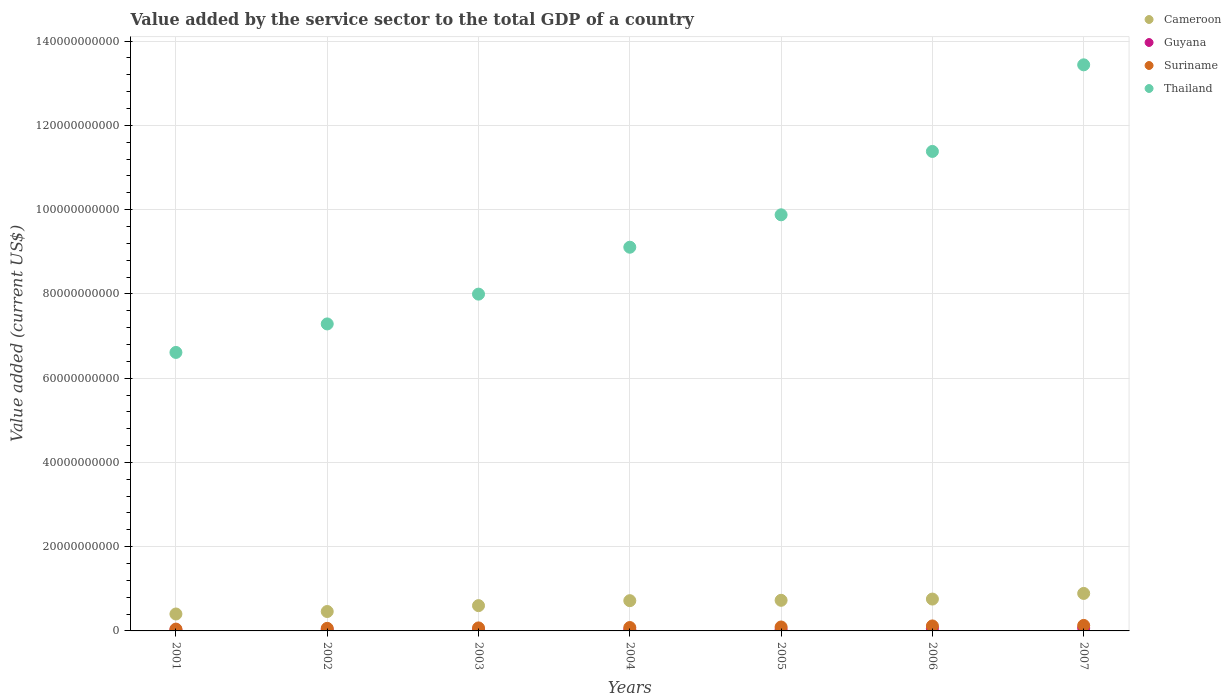Is the number of dotlines equal to the number of legend labels?
Your response must be concise. Yes. What is the value added by the service sector to the total GDP in Guyana in 2001?
Make the answer very short. 2.44e+08. Across all years, what is the maximum value added by the service sector to the total GDP in Thailand?
Ensure brevity in your answer.  1.34e+11. Across all years, what is the minimum value added by the service sector to the total GDP in Cameroon?
Your response must be concise. 4.02e+09. In which year was the value added by the service sector to the total GDP in Suriname maximum?
Make the answer very short. 2007. What is the total value added by the service sector to the total GDP in Cameroon in the graph?
Make the answer very short. 4.55e+1. What is the difference between the value added by the service sector to the total GDP in Thailand in 2005 and that in 2006?
Provide a succinct answer. -1.50e+1. What is the difference between the value added by the service sector to the total GDP in Thailand in 2006 and the value added by the service sector to the total GDP in Guyana in 2007?
Ensure brevity in your answer.  1.13e+11. What is the average value added by the service sector to the total GDP in Suriname per year?
Make the answer very short. 8.54e+08. In the year 2001, what is the difference between the value added by the service sector to the total GDP in Guyana and value added by the service sector to the total GDP in Suriname?
Offer a terse response. -1.87e+08. In how many years, is the value added by the service sector to the total GDP in Cameroon greater than 64000000000 US$?
Your response must be concise. 0. What is the ratio of the value added by the service sector to the total GDP in Cameroon in 2002 to that in 2005?
Your response must be concise. 0.63. Is the value added by the service sector to the total GDP in Guyana in 2001 less than that in 2007?
Your answer should be compact. Yes. What is the difference between the highest and the second highest value added by the service sector to the total GDP in Cameroon?
Ensure brevity in your answer.  1.34e+09. What is the difference between the highest and the lowest value added by the service sector to the total GDP in Suriname?
Ensure brevity in your answer.  8.72e+08. Is the value added by the service sector to the total GDP in Guyana strictly greater than the value added by the service sector to the total GDP in Cameroon over the years?
Your response must be concise. No. How many dotlines are there?
Give a very brief answer. 4. What is the difference between two consecutive major ticks on the Y-axis?
Your answer should be compact. 2.00e+1. Are the values on the major ticks of Y-axis written in scientific E-notation?
Your answer should be very brief. No. What is the title of the graph?
Your answer should be compact. Value added by the service sector to the total GDP of a country. Does "Sri Lanka" appear as one of the legend labels in the graph?
Offer a very short reply. No. What is the label or title of the X-axis?
Make the answer very short. Years. What is the label or title of the Y-axis?
Give a very brief answer. Value added (current US$). What is the Value added (current US$) of Cameroon in 2001?
Provide a succinct answer. 4.02e+09. What is the Value added (current US$) of Guyana in 2001?
Keep it short and to the point. 2.44e+08. What is the Value added (current US$) in Suriname in 2001?
Make the answer very short. 4.31e+08. What is the Value added (current US$) in Thailand in 2001?
Make the answer very short. 6.61e+1. What is the Value added (current US$) in Cameroon in 2002?
Offer a very short reply. 4.61e+09. What is the Value added (current US$) in Guyana in 2002?
Your response must be concise. 2.51e+08. What is the Value added (current US$) in Suriname in 2002?
Give a very brief answer. 6.11e+08. What is the Value added (current US$) in Thailand in 2002?
Provide a short and direct response. 7.29e+1. What is the Value added (current US$) in Cameroon in 2003?
Provide a short and direct response. 6.00e+09. What is the Value added (current US$) of Guyana in 2003?
Offer a very short reply. 2.63e+08. What is the Value added (current US$) in Suriname in 2003?
Offer a terse response. 7.13e+08. What is the Value added (current US$) in Thailand in 2003?
Provide a short and direct response. 7.99e+1. What is the Value added (current US$) in Cameroon in 2004?
Make the answer very short. 7.18e+09. What is the Value added (current US$) in Guyana in 2004?
Keep it short and to the point. 2.75e+08. What is the Value added (current US$) of Suriname in 2004?
Keep it short and to the point. 8.05e+08. What is the Value added (current US$) of Thailand in 2004?
Your answer should be compact. 9.11e+1. What is the Value added (current US$) of Cameroon in 2005?
Make the answer very short. 7.27e+09. What is the Value added (current US$) of Guyana in 2005?
Provide a short and direct response. 3.13e+08. What is the Value added (current US$) in Suriname in 2005?
Make the answer very short. 9.33e+08. What is the Value added (current US$) in Thailand in 2005?
Your response must be concise. 9.88e+1. What is the Value added (current US$) in Cameroon in 2006?
Give a very brief answer. 7.56e+09. What is the Value added (current US$) of Guyana in 2006?
Your answer should be compact. 6.05e+08. What is the Value added (current US$) of Suriname in 2006?
Provide a short and direct response. 1.18e+09. What is the Value added (current US$) of Thailand in 2006?
Provide a short and direct response. 1.14e+11. What is the Value added (current US$) in Cameroon in 2007?
Give a very brief answer. 8.90e+09. What is the Value added (current US$) of Guyana in 2007?
Offer a terse response. 6.90e+08. What is the Value added (current US$) of Suriname in 2007?
Give a very brief answer. 1.30e+09. What is the Value added (current US$) of Thailand in 2007?
Provide a short and direct response. 1.34e+11. Across all years, what is the maximum Value added (current US$) in Cameroon?
Make the answer very short. 8.90e+09. Across all years, what is the maximum Value added (current US$) in Guyana?
Offer a very short reply. 6.90e+08. Across all years, what is the maximum Value added (current US$) in Suriname?
Ensure brevity in your answer.  1.30e+09. Across all years, what is the maximum Value added (current US$) of Thailand?
Make the answer very short. 1.34e+11. Across all years, what is the minimum Value added (current US$) in Cameroon?
Offer a terse response. 4.02e+09. Across all years, what is the minimum Value added (current US$) in Guyana?
Provide a succinct answer. 2.44e+08. Across all years, what is the minimum Value added (current US$) of Suriname?
Make the answer very short. 4.31e+08. Across all years, what is the minimum Value added (current US$) in Thailand?
Make the answer very short. 6.61e+1. What is the total Value added (current US$) of Cameroon in the graph?
Your answer should be compact. 4.55e+1. What is the total Value added (current US$) of Guyana in the graph?
Give a very brief answer. 2.64e+09. What is the total Value added (current US$) of Suriname in the graph?
Make the answer very short. 5.98e+09. What is the total Value added (current US$) of Thailand in the graph?
Offer a terse response. 6.57e+11. What is the difference between the Value added (current US$) in Cameroon in 2001 and that in 2002?
Keep it short and to the point. -5.90e+08. What is the difference between the Value added (current US$) in Guyana in 2001 and that in 2002?
Offer a terse response. -6.45e+06. What is the difference between the Value added (current US$) in Suriname in 2001 and that in 2002?
Provide a short and direct response. -1.80e+08. What is the difference between the Value added (current US$) of Thailand in 2001 and that in 2002?
Your answer should be compact. -6.77e+09. What is the difference between the Value added (current US$) in Cameroon in 2001 and that in 2003?
Keep it short and to the point. -1.98e+09. What is the difference between the Value added (current US$) of Guyana in 2001 and that in 2003?
Keep it short and to the point. -1.88e+07. What is the difference between the Value added (current US$) in Suriname in 2001 and that in 2003?
Give a very brief answer. -2.82e+08. What is the difference between the Value added (current US$) of Thailand in 2001 and that in 2003?
Make the answer very short. -1.38e+1. What is the difference between the Value added (current US$) in Cameroon in 2001 and that in 2004?
Offer a very short reply. -3.16e+09. What is the difference between the Value added (current US$) in Guyana in 2001 and that in 2004?
Make the answer very short. -3.04e+07. What is the difference between the Value added (current US$) in Suriname in 2001 and that in 2004?
Ensure brevity in your answer.  -3.74e+08. What is the difference between the Value added (current US$) of Thailand in 2001 and that in 2004?
Your answer should be compact. -2.50e+1. What is the difference between the Value added (current US$) in Cameroon in 2001 and that in 2005?
Give a very brief answer. -3.25e+09. What is the difference between the Value added (current US$) of Guyana in 2001 and that in 2005?
Make the answer very short. -6.85e+07. What is the difference between the Value added (current US$) in Suriname in 2001 and that in 2005?
Your answer should be very brief. -5.02e+08. What is the difference between the Value added (current US$) in Thailand in 2001 and that in 2005?
Offer a terse response. -3.27e+1. What is the difference between the Value added (current US$) of Cameroon in 2001 and that in 2006?
Ensure brevity in your answer.  -3.54e+09. What is the difference between the Value added (current US$) of Guyana in 2001 and that in 2006?
Offer a very short reply. -3.61e+08. What is the difference between the Value added (current US$) of Suriname in 2001 and that in 2006?
Ensure brevity in your answer.  -7.52e+08. What is the difference between the Value added (current US$) of Thailand in 2001 and that in 2006?
Provide a short and direct response. -4.77e+1. What is the difference between the Value added (current US$) in Cameroon in 2001 and that in 2007?
Ensure brevity in your answer.  -4.88e+09. What is the difference between the Value added (current US$) of Guyana in 2001 and that in 2007?
Keep it short and to the point. -4.45e+08. What is the difference between the Value added (current US$) of Suriname in 2001 and that in 2007?
Your response must be concise. -8.72e+08. What is the difference between the Value added (current US$) in Thailand in 2001 and that in 2007?
Your answer should be compact. -6.83e+1. What is the difference between the Value added (current US$) in Cameroon in 2002 and that in 2003?
Provide a short and direct response. -1.39e+09. What is the difference between the Value added (current US$) in Guyana in 2002 and that in 2003?
Give a very brief answer. -1.23e+07. What is the difference between the Value added (current US$) in Suriname in 2002 and that in 2003?
Give a very brief answer. -1.02e+08. What is the difference between the Value added (current US$) in Thailand in 2002 and that in 2003?
Your answer should be compact. -7.07e+09. What is the difference between the Value added (current US$) in Cameroon in 2002 and that in 2004?
Provide a succinct answer. -2.57e+09. What is the difference between the Value added (current US$) of Guyana in 2002 and that in 2004?
Make the answer very short. -2.39e+07. What is the difference between the Value added (current US$) in Suriname in 2002 and that in 2004?
Make the answer very short. -1.94e+08. What is the difference between the Value added (current US$) in Thailand in 2002 and that in 2004?
Keep it short and to the point. -1.82e+1. What is the difference between the Value added (current US$) of Cameroon in 2002 and that in 2005?
Provide a succinct answer. -2.66e+09. What is the difference between the Value added (current US$) in Guyana in 2002 and that in 2005?
Your response must be concise. -6.21e+07. What is the difference between the Value added (current US$) in Suriname in 2002 and that in 2005?
Offer a terse response. -3.22e+08. What is the difference between the Value added (current US$) in Thailand in 2002 and that in 2005?
Make the answer very short. -2.59e+1. What is the difference between the Value added (current US$) of Cameroon in 2002 and that in 2006?
Make the answer very short. -2.95e+09. What is the difference between the Value added (current US$) of Guyana in 2002 and that in 2006?
Provide a succinct answer. -3.55e+08. What is the difference between the Value added (current US$) in Suriname in 2002 and that in 2006?
Keep it short and to the point. -5.72e+08. What is the difference between the Value added (current US$) in Thailand in 2002 and that in 2006?
Your answer should be compact. -4.09e+1. What is the difference between the Value added (current US$) in Cameroon in 2002 and that in 2007?
Make the answer very short. -4.29e+09. What is the difference between the Value added (current US$) in Guyana in 2002 and that in 2007?
Ensure brevity in your answer.  -4.39e+08. What is the difference between the Value added (current US$) in Suriname in 2002 and that in 2007?
Your answer should be very brief. -6.92e+08. What is the difference between the Value added (current US$) of Thailand in 2002 and that in 2007?
Your answer should be very brief. -6.15e+1. What is the difference between the Value added (current US$) of Cameroon in 2003 and that in 2004?
Ensure brevity in your answer.  -1.18e+09. What is the difference between the Value added (current US$) in Guyana in 2003 and that in 2004?
Your answer should be compact. -1.16e+07. What is the difference between the Value added (current US$) in Suriname in 2003 and that in 2004?
Offer a very short reply. -9.21e+07. What is the difference between the Value added (current US$) in Thailand in 2003 and that in 2004?
Provide a succinct answer. -1.11e+1. What is the difference between the Value added (current US$) in Cameroon in 2003 and that in 2005?
Your response must be concise. -1.27e+09. What is the difference between the Value added (current US$) in Guyana in 2003 and that in 2005?
Ensure brevity in your answer.  -4.98e+07. What is the difference between the Value added (current US$) of Suriname in 2003 and that in 2005?
Make the answer very short. -2.20e+08. What is the difference between the Value added (current US$) in Thailand in 2003 and that in 2005?
Give a very brief answer. -1.88e+1. What is the difference between the Value added (current US$) in Cameroon in 2003 and that in 2006?
Provide a succinct answer. -1.56e+09. What is the difference between the Value added (current US$) in Guyana in 2003 and that in 2006?
Make the answer very short. -3.42e+08. What is the difference between the Value added (current US$) in Suriname in 2003 and that in 2006?
Your response must be concise. -4.70e+08. What is the difference between the Value added (current US$) in Thailand in 2003 and that in 2006?
Make the answer very short. -3.39e+1. What is the difference between the Value added (current US$) of Cameroon in 2003 and that in 2007?
Offer a terse response. -2.90e+09. What is the difference between the Value added (current US$) in Guyana in 2003 and that in 2007?
Your answer should be compact. -4.27e+08. What is the difference between the Value added (current US$) in Suriname in 2003 and that in 2007?
Keep it short and to the point. -5.90e+08. What is the difference between the Value added (current US$) of Thailand in 2003 and that in 2007?
Ensure brevity in your answer.  -5.44e+1. What is the difference between the Value added (current US$) of Cameroon in 2004 and that in 2005?
Offer a terse response. -8.73e+07. What is the difference between the Value added (current US$) in Guyana in 2004 and that in 2005?
Your answer should be compact. -3.82e+07. What is the difference between the Value added (current US$) in Suriname in 2004 and that in 2005?
Give a very brief answer. -1.28e+08. What is the difference between the Value added (current US$) in Thailand in 2004 and that in 2005?
Ensure brevity in your answer.  -7.70e+09. What is the difference between the Value added (current US$) of Cameroon in 2004 and that in 2006?
Ensure brevity in your answer.  -3.81e+08. What is the difference between the Value added (current US$) of Guyana in 2004 and that in 2006?
Your answer should be compact. -3.31e+08. What is the difference between the Value added (current US$) of Suriname in 2004 and that in 2006?
Give a very brief answer. -3.78e+08. What is the difference between the Value added (current US$) of Thailand in 2004 and that in 2006?
Ensure brevity in your answer.  -2.27e+1. What is the difference between the Value added (current US$) of Cameroon in 2004 and that in 2007?
Provide a succinct answer. -1.72e+09. What is the difference between the Value added (current US$) of Guyana in 2004 and that in 2007?
Give a very brief answer. -4.15e+08. What is the difference between the Value added (current US$) of Suriname in 2004 and that in 2007?
Offer a terse response. -4.98e+08. What is the difference between the Value added (current US$) of Thailand in 2004 and that in 2007?
Provide a succinct answer. -4.33e+1. What is the difference between the Value added (current US$) in Cameroon in 2005 and that in 2006?
Make the answer very short. -2.94e+08. What is the difference between the Value added (current US$) in Guyana in 2005 and that in 2006?
Offer a terse response. -2.92e+08. What is the difference between the Value added (current US$) in Suriname in 2005 and that in 2006?
Offer a terse response. -2.50e+08. What is the difference between the Value added (current US$) of Thailand in 2005 and that in 2006?
Your response must be concise. -1.50e+1. What is the difference between the Value added (current US$) in Cameroon in 2005 and that in 2007?
Your answer should be very brief. -1.63e+09. What is the difference between the Value added (current US$) of Guyana in 2005 and that in 2007?
Your answer should be compact. -3.77e+08. What is the difference between the Value added (current US$) of Suriname in 2005 and that in 2007?
Offer a very short reply. -3.70e+08. What is the difference between the Value added (current US$) of Thailand in 2005 and that in 2007?
Ensure brevity in your answer.  -3.56e+1. What is the difference between the Value added (current US$) of Cameroon in 2006 and that in 2007?
Offer a terse response. -1.34e+09. What is the difference between the Value added (current US$) of Guyana in 2006 and that in 2007?
Give a very brief answer. -8.43e+07. What is the difference between the Value added (current US$) in Suriname in 2006 and that in 2007?
Your answer should be compact. -1.20e+08. What is the difference between the Value added (current US$) of Thailand in 2006 and that in 2007?
Make the answer very short. -2.06e+1. What is the difference between the Value added (current US$) of Cameroon in 2001 and the Value added (current US$) of Guyana in 2002?
Offer a terse response. 3.77e+09. What is the difference between the Value added (current US$) in Cameroon in 2001 and the Value added (current US$) in Suriname in 2002?
Ensure brevity in your answer.  3.41e+09. What is the difference between the Value added (current US$) in Cameroon in 2001 and the Value added (current US$) in Thailand in 2002?
Your answer should be compact. -6.89e+1. What is the difference between the Value added (current US$) of Guyana in 2001 and the Value added (current US$) of Suriname in 2002?
Provide a succinct answer. -3.67e+08. What is the difference between the Value added (current US$) of Guyana in 2001 and the Value added (current US$) of Thailand in 2002?
Your response must be concise. -7.26e+1. What is the difference between the Value added (current US$) of Suriname in 2001 and the Value added (current US$) of Thailand in 2002?
Keep it short and to the point. -7.24e+1. What is the difference between the Value added (current US$) in Cameroon in 2001 and the Value added (current US$) in Guyana in 2003?
Your response must be concise. 3.75e+09. What is the difference between the Value added (current US$) of Cameroon in 2001 and the Value added (current US$) of Suriname in 2003?
Your response must be concise. 3.30e+09. What is the difference between the Value added (current US$) of Cameroon in 2001 and the Value added (current US$) of Thailand in 2003?
Your response must be concise. -7.59e+1. What is the difference between the Value added (current US$) in Guyana in 2001 and the Value added (current US$) in Suriname in 2003?
Keep it short and to the point. -4.69e+08. What is the difference between the Value added (current US$) of Guyana in 2001 and the Value added (current US$) of Thailand in 2003?
Make the answer very short. -7.97e+1. What is the difference between the Value added (current US$) in Suriname in 2001 and the Value added (current US$) in Thailand in 2003?
Ensure brevity in your answer.  -7.95e+1. What is the difference between the Value added (current US$) of Cameroon in 2001 and the Value added (current US$) of Guyana in 2004?
Give a very brief answer. 3.74e+09. What is the difference between the Value added (current US$) of Cameroon in 2001 and the Value added (current US$) of Suriname in 2004?
Make the answer very short. 3.21e+09. What is the difference between the Value added (current US$) in Cameroon in 2001 and the Value added (current US$) in Thailand in 2004?
Your response must be concise. -8.71e+1. What is the difference between the Value added (current US$) in Guyana in 2001 and the Value added (current US$) in Suriname in 2004?
Give a very brief answer. -5.61e+08. What is the difference between the Value added (current US$) of Guyana in 2001 and the Value added (current US$) of Thailand in 2004?
Keep it short and to the point. -9.08e+1. What is the difference between the Value added (current US$) in Suriname in 2001 and the Value added (current US$) in Thailand in 2004?
Give a very brief answer. -9.06e+1. What is the difference between the Value added (current US$) in Cameroon in 2001 and the Value added (current US$) in Guyana in 2005?
Provide a succinct answer. 3.70e+09. What is the difference between the Value added (current US$) of Cameroon in 2001 and the Value added (current US$) of Suriname in 2005?
Keep it short and to the point. 3.08e+09. What is the difference between the Value added (current US$) in Cameroon in 2001 and the Value added (current US$) in Thailand in 2005?
Make the answer very short. -9.48e+1. What is the difference between the Value added (current US$) in Guyana in 2001 and the Value added (current US$) in Suriname in 2005?
Make the answer very short. -6.88e+08. What is the difference between the Value added (current US$) of Guyana in 2001 and the Value added (current US$) of Thailand in 2005?
Keep it short and to the point. -9.85e+1. What is the difference between the Value added (current US$) of Suriname in 2001 and the Value added (current US$) of Thailand in 2005?
Your response must be concise. -9.83e+1. What is the difference between the Value added (current US$) in Cameroon in 2001 and the Value added (current US$) in Guyana in 2006?
Offer a very short reply. 3.41e+09. What is the difference between the Value added (current US$) of Cameroon in 2001 and the Value added (current US$) of Suriname in 2006?
Keep it short and to the point. 2.83e+09. What is the difference between the Value added (current US$) of Cameroon in 2001 and the Value added (current US$) of Thailand in 2006?
Your answer should be very brief. -1.10e+11. What is the difference between the Value added (current US$) of Guyana in 2001 and the Value added (current US$) of Suriname in 2006?
Provide a succinct answer. -9.39e+08. What is the difference between the Value added (current US$) in Guyana in 2001 and the Value added (current US$) in Thailand in 2006?
Keep it short and to the point. -1.14e+11. What is the difference between the Value added (current US$) of Suriname in 2001 and the Value added (current US$) of Thailand in 2006?
Provide a succinct answer. -1.13e+11. What is the difference between the Value added (current US$) in Cameroon in 2001 and the Value added (current US$) in Guyana in 2007?
Your answer should be very brief. 3.33e+09. What is the difference between the Value added (current US$) of Cameroon in 2001 and the Value added (current US$) of Suriname in 2007?
Provide a short and direct response. 2.71e+09. What is the difference between the Value added (current US$) of Cameroon in 2001 and the Value added (current US$) of Thailand in 2007?
Provide a short and direct response. -1.30e+11. What is the difference between the Value added (current US$) in Guyana in 2001 and the Value added (current US$) in Suriname in 2007?
Provide a succinct answer. -1.06e+09. What is the difference between the Value added (current US$) in Guyana in 2001 and the Value added (current US$) in Thailand in 2007?
Give a very brief answer. -1.34e+11. What is the difference between the Value added (current US$) of Suriname in 2001 and the Value added (current US$) of Thailand in 2007?
Your response must be concise. -1.34e+11. What is the difference between the Value added (current US$) in Cameroon in 2002 and the Value added (current US$) in Guyana in 2003?
Provide a short and direct response. 4.34e+09. What is the difference between the Value added (current US$) of Cameroon in 2002 and the Value added (current US$) of Suriname in 2003?
Provide a short and direct response. 3.89e+09. What is the difference between the Value added (current US$) of Cameroon in 2002 and the Value added (current US$) of Thailand in 2003?
Your response must be concise. -7.53e+1. What is the difference between the Value added (current US$) of Guyana in 2002 and the Value added (current US$) of Suriname in 2003?
Offer a terse response. -4.62e+08. What is the difference between the Value added (current US$) of Guyana in 2002 and the Value added (current US$) of Thailand in 2003?
Your answer should be very brief. -7.97e+1. What is the difference between the Value added (current US$) of Suriname in 2002 and the Value added (current US$) of Thailand in 2003?
Offer a terse response. -7.93e+1. What is the difference between the Value added (current US$) of Cameroon in 2002 and the Value added (current US$) of Guyana in 2004?
Your response must be concise. 4.33e+09. What is the difference between the Value added (current US$) of Cameroon in 2002 and the Value added (current US$) of Suriname in 2004?
Give a very brief answer. 3.80e+09. What is the difference between the Value added (current US$) of Cameroon in 2002 and the Value added (current US$) of Thailand in 2004?
Your answer should be very brief. -8.65e+1. What is the difference between the Value added (current US$) in Guyana in 2002 and the Value added (current US$) in Suriname in 2004?
Your response must be concise. -5.54e+08. What is the difference between the Value added (current US$) of Guyana in 2002 and the Value added (current US$) of Thailand in 2004?
Your answer should be very brief. -9.08e+1. What is the difference between the Value added (current US$) in Suriname in 2002 and the Value added (current US$) in Thailand in 2004?
Offer a terse response. -9.05e+1. What is the difference between the Value added (current US$) of Cameroon in 2002 and the Value added (current US$) of Guyana in 2005?
Your answer should be very brief. 4.29e+09. What is the difference between the Value added (current US$) of Cameroon in 2002 and the Value added (current US$) of Suriname in 2005?
Your answer should be very brief. 3.68e+09. What is the difference between the Value added (current US$) of Cameroon in 2002 and the Value added (current US$) of Thailand in 2005?
Ensure brevity in your answer.  -9.42e+1. What is the difference between the Value added (current US$) in Guyana in 2002 and the Value added (current US$) in Suriname in 2005?
Ensure brevity in your answer.  -6.82e+08. What is the difference between the Value added (current US$) in Guyana in 2002 and the Value added (current US$) in Thailand in 2005?
Your answer should be compact. -9.85e+1. What is the difference between the Value added (current US$) of Suriname in 2002 and the Value added (current US$) of Thailand in 2005?
Keep it short and to the point. -9.82e+1. What is the difference between the Value added (current US$) of Cameroon in 2002 and the Value added (current US$) of Guyana in 2006?
Offer a very short reply. 4.00e+09. What is the difference between the Value added (current US$) of Cameroon in 2002 and the Value added (current US$) of Suriname in 2006?
Make the answer very short. 3.42e+09. What is the difference between the Value added (current US$) in Cameroon in 2002 and the Value added (current US$) in Thailand in 2006?
Provide a succinct answer. -1.09e+11. What is the difference between the Value added (current US$) of Guyana in 2002 and the Value added (current US$) of Suriname in 2006?
Provide a succinct answer. -9.32e+08. What is the difference between the Value added (current US$) of Guyana in 2002 and the Value added (current US$) of Thailand in 2006?
Make the answer very short. -1.14e+11. What is the difference between the Value added (current US$) in Suriname in 2002 and the Value added (current US$) in Thailand in 2006?
Provide a short and direct response. -1.13e+11. What is the difference between the Value added (current US$) in Cameroon in 2002 and the Value added (current US$) in Guyana in 2007?
Give a very brief answer. 3.92e+09. What is the difference between the Value added (current US$) of Cameroon in 2002 and the Value added (current US$) of Suriname in 2007?
Provide a short and direct response. 3.30e+09. What is the difference between the Value added (current US$) of Cameroon in 2002 and the Value added (current US$) of Thailand in 2007?
Ensure brevity in your answer.  -1.30e+11. What is the difference between the Value added (current US$) in Guyana in 2002 and the Value added (current US$) in Suriname in 2007?
Provide a short and direct response. -1.05e+09. What is the difference between the Value added (current US$) in Guyana in 2002 and the Value added (current US$) in Thailand in 2007?
Give a very brief answer. -1.34e+11. What is the difference between the Value added (current US$) of Suriname in 2002 and the Value added (current US$) of Thailand in 2007?
Your response must be concise. -1.34e+11. What is the difference between the Value added (current US$) in Cameroon in 2003 and the Value added (current US$) in Guyana in 2004?
Your response must be concise. 5.73e+09. What is the difference between the Value added (current US$) of Cameroon in 2003 and the Value added (current US$) of Suriname in 2004?
Your response must be concise. 5.20e+09. What is the difference between the Value added (current US$) of Cameroon in 2003 and the Value added (current US$) of Thailand in 2004?
Provide a succinct answer. -8.51e+1. What is the difference between the Value added (current US$) in Guyana in 2003 and the Value added (current US$) in Suriname in 2004?
Provide a succinct answer. -5.42e+08. What is the difference between the Value added (current US$) of Guyana in 2003 and the Value added (current US$) of Thailand in 2004?
Offer a very short reply. -9.08e+1. What is the difference between the Value added (current US$) in Suriname in 2003 and the Value added (current US$) in Thailand in 2004?
Offer a terse response. -9.04e+1. What is the difference between the Value added (current US$) of Cameroon in 2003 and the Value added (current US$) of Guyana in 2005?
Your answer should be compact. 5.69e+09. What is the difference between the Value added (current US$) in Cameroon in 2003 and the Value added (current US$) in Suriname in 2005?
Offer a terse response. 5.07e+09. What is the difference between the Value added (current US$) of Cameroon in 2003 and the Value added (current US$) of Thailand in 2005?
Offer a very short reply. -9.28e+1. What is the difference between the Value added (current US$) in Guyana in 2003 and the Value added (current US$) in Suriname in 2005?
Your answer should be very brief. -6.70e+08. What is the difference between the Value added (current US$) in Guyana in 2003 and the Value added (current US$) in Thailand in 2005?
Offer a very short reply. -9.85e+1. What is the difference between the Value added (current US$) in Suriname in 2003 and the Value added (current US$) in Thailand in 2005?
Give a very brief answer. -9.81e+1. What is the difference between the Value added (current US$) of Cameroon in 2003 and the Value added (current US$) of Guyana in 2006?
Give a very brief answer. 5.40e+09. What is the difference between the Value added (current US$) of Cameroon in 2003 and the Value added (current US$) of Suriname in 2006?
Give a very brief answer. 4.82e+09. What is the difference between the Value added (current US$) of Cameroon in 2003 and the Value added (current US$) of Thailand in 2006?
Make the answer very short. -1.08e+11. What is the difference between the Value added (current US$) in Guyana in 2003 and the Value added (current US$) in Suriname in 2006?
Provide a succinct answer. -9.20e+08. What is the difference between the Value added (current US$) of Guyana in 2003 and the Value added (current US$) of Thailand in 2006?
Your response must be concise. -1.14e+11. What is the difference between the Value added (current US$) of Suriname in 2003 and the Value added (current US$) of Thailand in 2006?
Keep it short and to the point. -1.13e+11. What is the difference between the Value added (current US$) of Cameroon in 2003 and the Value added (current US$) of Guyana in 2007?
Provide a short and direct response. 5.31e+09. What is the difference between the Value added (current US$) in Cameroon in 2003 and the Value added (current US$) in Suriname in 2007?
Provide a succinct answer. 4.70e+09. What is the difference between the Value added (current US$) in Cameroon in 2003 and the Value added (current US$) in Thailand in 2007?
Offer a terse response. -1.28e+11. What is the difference between the Value added (current US$) of Guyana in 2003 and the Value added (current US$) of Suriname in 2007?
Your answer should be compact. -1.04e+09. What is the difference between the Value added (current US$) in Guyana in 2003 and the Value added (current US$) in Thailand in 2007?
Make the answer very short. -1.34e+11. What is the difference between the Value added (current US$) in Suriname in 2003 and the Value added (current US$) in Thailand in 2007?
Offer a terse response. -1.34e+11. What is the difference between the Value added (current US$) in Cameroon in 2004 and the Value added (current US$) in Guyana in 2005?
Provide a short and direct response. 6.87e+09. What is the difference between the Value added (current US$) in Cameroon in 2004 and the Value added (current US$) in Suriname in 2005?
Keep it short and to the point. 6.25e+09. What is the difference between the Value added (current US$) in Cameroon in 2004 and the Value added (current US$) in Thailand in 2005?
Provide a succinct answer. -9.16e+1. What is the difference between the Value added (current US$) of Guyana in 2004 and the Value added (current US$) of Suriname in 2005?
Offer a terse response. -6.58e+08. What is the difference between the Value added (current US$) of Guyana in 2004 and the Value added (current US$) of Thailand in 2005?
Your answer should be very brief. -9.85e+1. What is the difference between the Value added (current US$) in Suriname in 2004 and the Value added (current US$) in Thailand in 2005?
Your response must be concise. -9.80e+1. What is the difference between the Value added (current US$) of Cameroon in 2004 and the Value added (current US$) of Guyana in 2006?
Provide a succinct answer. 6.57e+09. What is the difference between the Value added (current US$) in Cameroon in 2004 and the Value added (current US$) in Suriname in 2006?
Your answer should be very brief. 6.00e+09. What is the difference between the Value added (current US$) in Cameroon in 2004 and the Value added (current US$) in Thailand in 2006?
Your answer should be very brief. -1.07e+11. What is the difference between the Value added (current US$) in Guyana in 2004 and the Value added (current US$) in Suriname in 2006?
Make the answer very short. -9.08e+08. What is the difference between the Value added (current US$) of Guyana in 2004 and the Value added (current US$) of Thailand in 2006?
Your answer should be compact. -1.14e+11. What is the difference between the Value added (current US$) of Suriname in 2004 and the Value added (current US$) of Thailand in 2006?
Your response must be concise. -1.13e+11. What is the difference between the Value added (current US$) of Cameroon in 2004 and the Value added (current US$) of Guyana in 2007?
Offer a terse response. 6.49e+09. What is the difference between the Value added (current US$) in Cameroon in 2004 and the Value added (current US$) in Suriname in 2007?
Give a very brief answer. 5.88e+09. What is the difference between the Value added (current US$) in Cameroon in 2004 and the Value added (current US$) in Thailand in 2007?
Provide a short and direct response. -1.27e+11. What is the difference between the Value added (current US$) in Guyana in 2004 and the Value added (current US$) in Suriname in 2007?
Offer a very short reply. -1.03e+09. What is the difference between the Value added (current US$) of Guyana in 2004 and the Value added (current US$) of Thailand in 2007?
Provide a short and direct response. -1.34e+11. What is the difference between the Value added (current US$) in Suriname in 2004 and the Value added (current US$) in Thailand in 2007?
Your response must be concise. -1.34e+11. What is the difference between the Value added (current US$) of Cameroon in 2005 and the Value added (current US$) of Guyana in 2006?
Provide a succinct answer. 6.66e+09. What is the difference between the Value added (current US$) in Cameroon in 2005 and the Value added (current US$) in Suriname in 2006?
Your answer should be very brief. 6.08e+09. What is the difference between the Value added (current US$) of Cameroon in 2005 and the Value added (current US$) of Thailand in 2006?
Keep it short and to the point. -1.07e+11. What is the difference between the Value added (current US$) in Guyana in 2005 and the Value added (current US$) in Suriname in 2006?
Ensure brevity in your answer.  -8.70e+08. What is the difference between the Value added (current US$) of Guyana in 2005 and the Value added (current US$) of Thailand in 2006?
Keep it short and to the point. -1.14e+11. What is the difference between the Value added (current US$) in Suriname in 2005 and the Value added (current US$) in Thailand in 2006?
Ensure brevity in your answer.  -1.13e+11. What is the difference between the Value added (current US$) in Cameroon in 2005 and the Value added (current US$) in Guyana in 2007?
Provide a short and direct response. 6.58e+09. What is the difference between the Value added (current US$) of Cameroon in 2005 and the Value added (current US$) of Suriname in 2007?
Your answer should be compact. 5.96e+09. What is the difference between the Value added (current US$) of Cameroon in 2005 and the Value added (current US$) of Thailand in 2007?
Offer a terse response. -1.27e+11. What is the difference between the Value added (current US$) in Guyana in 2005 and the Value added (current US$) in Suriname in 2007?
Give a very brief answer. -9.90e+08. What is the difference between the Value added (current US$) of Guyana in 2005 and the Value added (current US$) of Thailand in 2007?
Offer a very short reply. -1.34e+11. What is the difference between the Value added (current US$) in Suriname in 2005 and the Value added (current US$) in Thailand in 2007?
Make the answer very short. -1.33e+11. What is the difference between the Value added (current US$) of Cameroon in 2006 and the Value added (current US$) of Guyana in 2007?
Keep it short and to the point. 6.87e+09. What is the difference between the Value added (current US$) in Cameroon in 2006 and the Value added (current US$) in Suriname in 2007?
Make the answer very short. 6.26e+09. What is the difference between the Value added (current US$) of Cameroon in 2006 and the Value added (current US$) of Thailand in 2007?
Keep it short and to the point. -1.27e+11. What is the difference between the Value added (current US$) of Guyana in 2006 and the Value added (current US$) of Suriname in 2007?
Your response must be concise. -6.98e+08. What is the difference between the Value added (current US$) of Guyana in 2006 and the Value added (current US$) of Thailand in 2007?
Make the answer very short. -1.34e+11. What is the difference between the Value added (current US$) in Suriname in 2006 and the Value added (current US$) in Thailand in 2007?
Offer a terse response. -1.33e+11. What is the average Value added (current US$) of Cameroon per year?
Your answer should be compact. 6.51e+09. What is the average Value added (current US$) in Guyana per year?
Ensure brevity in your answer.  3.77e+08. What is the average Value added (current US$) of Suriname per year?
Keep it short and to the point. 8.54e+08. What is the average Value added (current US$) of Thailand per year?
Provide a short and direct response. 9.39e+1. In the year 2001, what is the difference between the Value added (current US$) in Cameroon and Value added (current US$) in Guyana?
Your response must be concise. 3.77e+09. In the year 2001, what is the difference between the Value added (current US$) in Cameroon and Value added (current US$) in Suriname?
Offer a terse response. 3.59e+09. In the year 2001, what is the difference between the Value added (current US$) of Cameroon and Value added (current US$) of Thailand?
Your answer should be very brief. -6.21e+1. In the year 2001, what is the difference between the Value added (current US$) in Guyana and Value added (current US$) in Suriname?
Keep it short and to the point. -1.87e+08. In the year 2001, what is the difference between the Value added (current US$) in Guyana and Value added (current US$) in Thailand?
Your response must be concise. -6.59e+1. In the year 2001, what is the difference between the Value added (current US$) of Suriname and Value added (current US$) of Thailand?
Make the answer very short. -6.57e+1. In the year 2002, what is the difference between the Value added (current US$) of Cameroon and Value added (current US$) of Guyana?
Provide a short and direct response. 4.36e+09. In the year 2002, what is the difference between the Value added (current US$) in Cameroon and Value added (current US$) in Suriname?
Your answer should be very brief. 4.00e+09. In the year 2002, what is the difference between the Value added (current US$) of Cameroon and Value added (current US$) of Thailand?
Make the answer very short. -6.83e+1. In the year 2002, what is the difference between the Value added (current US$) of Guyana and Value added (current US$) of Suriname?
Offer a very short reply. -3.61e+08. In the year 2002, what is the difference between the Value added (current US$) of Guyana and Value added (current US$) of Thailand?
Keep it short and to the point. -7.26e+1. In the year 2002, what is the difference between the Value added (current US$) of Suriname and Value added (current US$) of Thailand?
Ensure brevity in your answer.  -7.23e+1. In the year 2003, what is the difference between the Value added (current US$) in Cameroon and Value added (current US$) in Guyana?
Provide a succinct answer. 5.74e+09. In the year 2003, what is the difference between the Value added (current US$) in Cameroon and Value added (current US$) in Suriname?
Offer a terse response. 5.29e+09. In the year 2003, what is the difference between the Value added (current US$) of Cameroon and Value added (current US$) of Thailand?
Give a very brief answer. -7.39e+1. In the year 2003, what is the difference between the Value added (current US$) in Guyana and Value added (current US$) in Suriname?
Keep it short and to the point. -4.50e+08. In the year 2003, what is the difference between the Value added (current US$) of Guyana and Value added (current US$) of Thailand?
Ensure brevity in your answer.  -7.97e+1. In the year 2003, what is the difference between the Value added (current US$) of Suriname and Value added (current US$) of Thailand?
Give a very brief answer. -7.92e+1. In the year 2004, what is the difference between the Value added (current US$) of Cameroon and Value added (current US$) of Guyana?
Give a very brief answer. 6.91e+09. In the year 2004, what is the difference between the Value added (current US$) in Cameroon and Value added (current US$) in Suriname?
Make the answer very short. 6.37e+09. In the year 2004, what is the difference between the Value added (current US$) of Cameroon and Value added (current US$) of Thailand?
Keep it short and to the point. -8.39e+1. In the year 2004, what is the difference between the Value added (current US$) of Guyana and Value added (current US$) of Suriname?
Your answer should be compact. -5.30e+08. In the year 2004, what is the difference between the Value added (current US$) of Guyana and Value added (current US$) of Thailand?
Provide a short and direct response. -9.08e+1. In the year 2004, what is the difference between the Value added (current US$) in Suriname and Value added (current US$) in Thailand?
Ensure brevity in your answer.  -9.03e+1. In the year 2005, what is the difference between the Value added (current US$) in Cameroon and Value added (current US$) in Guyana?
Give a very brief answer. 6.95e+09. In the year 2005, what is the difference between the Value added (current US$) of Cameroon and Value added (current US$) of Suriname?
Give a very brief answer. 6.33e+09. In the year 2005, what is the difference between the Value added (current US$) of Cameroon and Value added (current US$) of Thailand?
Offer a terse response. -9.15e+1. In the year 2005, what is the difference between the Value added (current US$) of Guyana and Value added (current US$) of Suriname?
Ensure brevity in your answer.  -6.20e+08. In the year 2005, what is the difference between the Value added (current US$) of Guyana and Value added (current US$) of Thailand?
Your answer should be compact. -9.85e+1. In the year 2005, what is the difference between the Value added (current US$) in Suriname and Value added (current US$) in Thailand?
Give a very brief answer. -9.78e+1. In the year 2006, what is the difference between the Value added (current US$) of Cameroon and Value added (current US$) of Guyana?
Your answer should be very brief. 6.96e+09. In the year 2006, what is the difference between the Value added (current US$) of Cameroon and Value added (current US$) of Suriname?
Keep it short and to the point. 6.38e+09. In the year 2006, what is the difference between the Value added (current US$) of Cameroon and Value added (current US$) of Thailand?
Give a very brief answer. -1.06e+11. In the year 2006, what is the difference between the Value added (current US$) of Guyana and Value added (current US$) of Suriname?
Offer a very short reply. -5.78e+08. In the year 2006, what is the difference between the Value added (current US$) in Guyana and Value added (current US$) in Thailand?
Offer a terse response. -1.13e+11. In the year 2006, what is the difference between the Value added (current US$) of Suriname and Value added (current US$) of Thailand?
Give a very brief answer. -1.13e+11. In the year 2007, what is the difference between the Value added (current US$) of Cameroon and Value added (current US$) of Guyana?
Your response must be concise. 8.21e+09. In the year 2007, what is the difference between the Value added (current US$) in Cameroon and Value added (current US$) in Suriname?
Your answer should be very brief. 7.60e+09. In the year 2007, what is the difference between the Value added (current US$) of Cameroon and Value added (current US$) of Thailand?
Offer a very short reply. -1.25e+11. In the year 2007, what is the difference between the Value added (current US$) of Guyana and Value added (current US$) of Suriname?
Offer a terse response. -6.14e+08. In the year 2007, what is the difference between the Value added (current US$) in Guyana and Value added (current US$) in Thailand?
Ensure brevity in your answer.  -1.34e+11. In the year 2007, what is the difference between the Value added (current US$) of Suriname and Value added (current US$) of Thailand?
Offer a terse response. -1.33e+11. What is the ratio of the Value added (current US$) in Cameroon in 2001 to that in 2002?
Provide a succinct answer. 0.87. What is the ratio of the Value added (current US$) in Guyana in 2001 to that in 2002?
Your answer should be compact. 0.97. What is the ratio of the Value added (current US$) in Suriname in 2001 to that in 2002?
Your response must be concise. 0.7. What is the ratio of the Value added (current US$) of Thailand in 2001 to that in 2002?
Ensure brevity in your answer.  0.91. What is the ratio of the Value added (current US$) of Cameroon in 2001 to that in 2003?
Your answer should be compact. 0.67. What is the ratio of the Value added (current US$) in Guyana in 2001 to that in 2003?
Provide a short and direct response. 0.93. What is the ratio of the Value added (current US$) in Suriname in 2001 to that in 2003?
Make the answer very short. 0.6. What is the ratio of the Value added (current US$) of Thailand in 2001 to that in 2003?
Offer a very short reply. 0.83. What is the ratio of the Value added (current US$) in Cameroon in 2001 to that in 2004?
Offer a very short reply. 0.56. What is the ratio of the Value added (current US$) in Guyana in 2001 to that in 2004?
Ensure brevity in your answer.  0.89. What is the ratio of the Value added (current US$) of Suriname in 2001 to that in 2004?
Your response must be concise. 0.54. What is the ratio of the Value added (current US$) in Thailand in 2001 to that in 2004?
Provide a short and direct response. 0.73. What is the ratio of the Value added (current US$) in Cameroon in 2001 to that in 2005?
Provide a succinct answer. 0.55. What is the ratio of the Value added (current US$) of Guyana in 2001 to that in 2005?
Ensure brevity in your answer.  0.78. What is the ratio of the Value added (current US$) in Suriname in 2001 to that in 2005?
Provide a short and direct response. 0.46. What is the ratio of the Value added (current US$) of Thailand in 2001 to that in 2005?
Your answer should be compact. 0.67. What is the ratio of the Value added (current US$) of Cameroon in 2001 to that in 2006?
Your response must be concise. 0.53. What is the ratio of the Value added (current US$) of Guyana in 2001 to that in 2006?
Your answer should be compact. 0.4. What is the ratio of the Value added (current US$) in Suriname in 2001 to that in 2006?
Your answer should be compact. 0.36. What is the ratio of the Value added (current US$) in Thailand in 2001 to that in 2006?
Your response must be concise. 0.58. What is the ratio of the Value added (current US$) in Cameroon in 2001 to that in 2007?
Offer a terse response. 0.45. What is the ratio of the Value added (current US$) in Guyana in 2001 to that in 2007?
Provide a short and direct response. 0.35. What is the ratio of the Value added (current US$) in Suriname in 2001 to that in 2007?
Keep it short and to the point. 0.33. What is the ratio of the Value added (current US$) in Thailand in 2001 to that in 2007?
Provide a short and direct response. 0.49. What is the ratio of the Value added (current US$) in Cameroon in 2002 to that in 2003?
Your answer should be very brief. 0.77. What is the ratio of the Value added (current US$) of Guyana in 2002 to that in 2003?
Offer a terse response. 0.95. What is the ratio of the Value added (current US$) of Suriname in 2002 to that in 2003?
Provide a succinct answer. 0.86. What is the ratio of the Value added (current US$) of Thailand in 2002 to that in 2003?
Your answer should be compact. 0.91. What is the ratio of the Value added (current US$) in Cameroon in 2002 to that in 2004?
Give a very brief answer. 0.64. What is the ratio of the Value added (current US$) of Guyana in 2002 to that in 2004?
Provide a short and direct response. 0.91. What is the ratio of the Value added (current US$) in Suriname in 2002 to that in 2004?
Your answer should be compact. 0.76. What is the ratio of the Value added (current US$) of Thailand in 2002 to that in 2004?
Offer a terse response. 0.8. What is the ratio of the Value added (current US$) of Cameroon in 2002 to that in 2005?
Make the answer very short. 0.63. What is the ratio of the Value added (current US$) in Guyana in 2002 to that in 2005?
Your answer should be very brief. 0.8. What is the ratio of the Value added (current US$) of Suriname in 2002 to that in 2005?
Your response must be concise. 0.66. What is the ratio of the Value added (current US$) of Thailand in 2002 to that in 2005?
Make the answer very short. 0.74. What is the ratio of the Value added (current US$) in Cameroon in 2002 to that in 2006?
Your answer should be very brief. 0.61. What is the ratio of the Value added (current US$) of Guyana in 2002 to that in 2006?
Make the answer very short. 0.41. What is the ratio of the Value added (current US$) of Suriname in 2002 to that in 2006?
Offer a terse response. 0.52. What is the ratio of the Value added (current US$) in Thailand in 2002 to that in 2006?
Offer a terse response. 0.64. What is the ratio of the Value added (current US$) of Cameroon in 2002 to that in 2007?
Your response must be concise. 0.52. What is the ratio of the Value added (current US$) of Guyana in 2002 to that in 2007?
Your answer should be compact. 0.36. What is the ratio of the Value added (current US$) of Suriname in 2002 to that in 2007?
Offer a very short reply. 0.47. What is the ratio of the Value added (current US$) in Thailand in 2002 to that in 2007?
Make the answer very short. 0.54. What is the ratio of the Value added (current US$) of Cameroon in 2003 to that in 2004?
Provide a succinct answer. 0.84. What is the ratio of the Value added (current US$) of Guyana in 2003 to that in 2004?
Provide a short and direct response. 0.96. What is the ratio of the Value added (current US$) of Suriname in 2003 to that in 2004?
Offer a terse response. 0.89. What is the ratio of the Value added (current US$) in Thailand in 2003 to that in 2004?
Offer a very short reply. 0.88. What is the ratio of the Value added (current US$) of Cameroon in 2003 to that in 2005?
Give a very brief answer. 0.83. What is the ratio of the Value added (current US$) of Guyana in 2003 to that in 2005?
Provide a short and direct response. 0.84. What is the ratio of the Value added (current US$) in Suriname in 2003 to that in 2005?
Your answer should be compact. 0.76. What is the ratio of the Value added (current US$) in Thailand in 2003 to that in 2005?
Give a very brief answer. 0.81. What is the ratio of the Value added (current US$) in Cameroon in 2003 to that in 2006?
Offer a terse response. 0.79. What is the ratio of the Value added (current US$) of Guyana in 2003 to that in 2006?
Keep it short and to the point. 0.43. What is the ratio of the Value added (current US$) of Suriname in 2003 to that in 2006?
Offer a terse response. 0.6. What is the ratio of the Value added (current US$) of Thailand in 2003 to that in 2006?
Provide a short and direct response. 0.7. What is the ratio of the Value added (current US$) of Cameroon in 2003 to that in 2007?
Provide a succinct answer. 0.67. What is the ratio of the Value added (current US$) in Guyana in 2003 to that in 2007?
Offer a very short reply. 0.38. What is the ratio of the Value added (current US$) of Suriname in 2003 to that in 2007?
Provide a short and direct response. 0.55. What is the ratio of the Value added (current US$) in Thailand in 2003 to that in 2007?
Keep it short and to the point. 0.59. What is the ratio of the Value added (current US$) in Guyana in 2004 to that in 2005?
Your answer should be compact. 0.88. What is the ratio of the Value added (current US$) of Suriname in 2004 to that in 2005?
Keep it short and to the point. 0.86. What is the ratio of the Value added (current US$) of Thailand in 2004 to that in 2005?
Ensure brevity in your answer.  0.92. What is the ratio of the Value added (current US$) of Cameroon in 2004 to that in 2006?
Offer a terse response. 0.95. What is the ratio of the Value added (current US$) in Guyana in 2004 to that in 2006?
Your answer should be very brief. 0.45. What is the ratio of the Value added (current US$) in Suriname in 2004 to that in 2006?
Make the answer very short. 0.68. What is the ratio of the Value added (current US$) of Thailand in 2004 to that in 2006?
Your response must be concise. 0.8. What is the ratio of the Value added (current US$) of Cameroon in 2004 to that in 2007?
Your answer should be very brief. 0.81. What is the ratio of the Value added (current US$) of Guyana in 2004 to that in 2007?
Make the answer very short. 0.4. What is the ratio of the Value added (current US$) of Suriname in 2004 to that in 2007?
Provide a short and direct response. 0.62. What is the ratio of the Value added (current US$) of Thailand in 2004 to that in 2007?
Make the answer very short. 0.68. What is the ratio of the Value added (current US$) in Cameroon in 2005 to that in 2006?
Your response must be concise. 0.96. What is the ratio of the Value added (current US$) in Guyana in 2005 to that in 2006?
Your response must be concise. 0.52. What is the ratio of the Value added (current US$) in Suriname in 2005 to that in 2006?
Provide a succinct answer. 0.79. What is the ratio of the Value added (current US$) in Thailand in 2005 to that in 2006?
Offer a terse response. 0.87. What is the ratio of the Value added (current US$) in Cameroon in 2005 to that in 2007?
Offer a very short reply. 0.82. What is the ratio of the Value added (current US$) in Guyana in 2005 to that in 2007?
Give a very brief answer. 0.45. What is the ratio of the Value added (current US$) of Suriname in 2005 to that in 2007?
Give a very brief answer. 0.72. What is the ratio of the Value added (current US$) in Thailand in 2005 to that in 2007?
Offer a very short reply. 0.74. What is the ratio of the Value added (current US$) in Cameroon in 2006 to that in 2007?
Give a very brief answer. 0.85. What is the ratio of the Value added (current US$) in Guyana in 2006 to that in 2007?
Your answer should be very brief. 0.88. What is the ratio of the Value added (current US$) in Suriname in 2006 to that in 2007?
Offer a terse response. 0.91. What is the ratio of the Value added (current US$) of Thailand in 2006 to that in 2007?
Ensure brevity in your answer.  0.85. What is the difference between the highest and the second highest Value added (current US$) in Cameroon?
Make the answer very short. 1.34e+09. What is the difference between the highest and the second highest Value added (current US$) of Guyana?
Make the answer very short. 8.43e+07. What is the difference between the highest and the second highest Value added (current US$) of Suriname?
Ensure brevity in your answer.  1.20e+08. What is the difference between the highest and the second highest Value added (current US$) in Thailand?
Offer a very short reply. 2.06e+1. What is the difference between the highest and the lowest Value added (current US$) of Cameroon?
Your answer should be very brief. 4.88e+09. What is the difference between the highest and the lowest Value added (current US$) of Guyana?
Your answer should be very brief. 4.45e+08. What is the difference between the highest and the lowest Value added (current US$) in Suriname?
Ensure brevity in your answer.  8.72e+08. What is the difference between the highest and the lowest Value added (current US$) of Thailand?
Provide a short and direct response. 6.83e+1. 